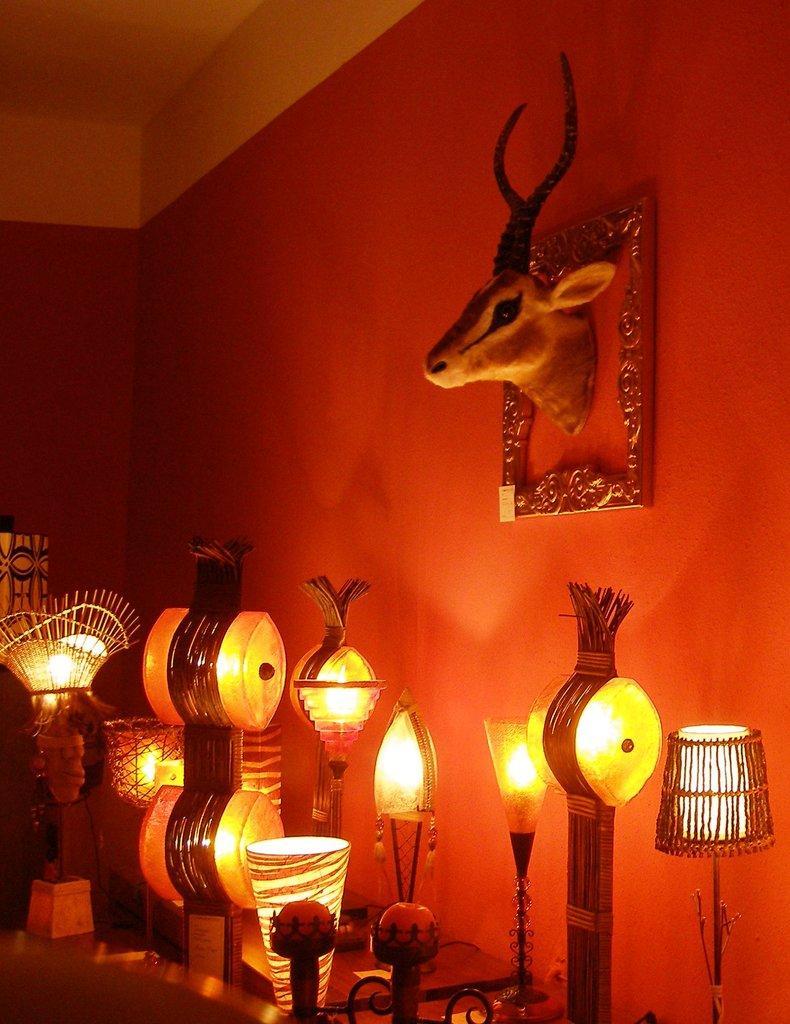Please provide a concise description of this image. At the bottom of the image, we can see so many table lamps. Background there is a wall. Here we can see animal shaped showpiece and frame. Top of the image, there is a ceiling. 